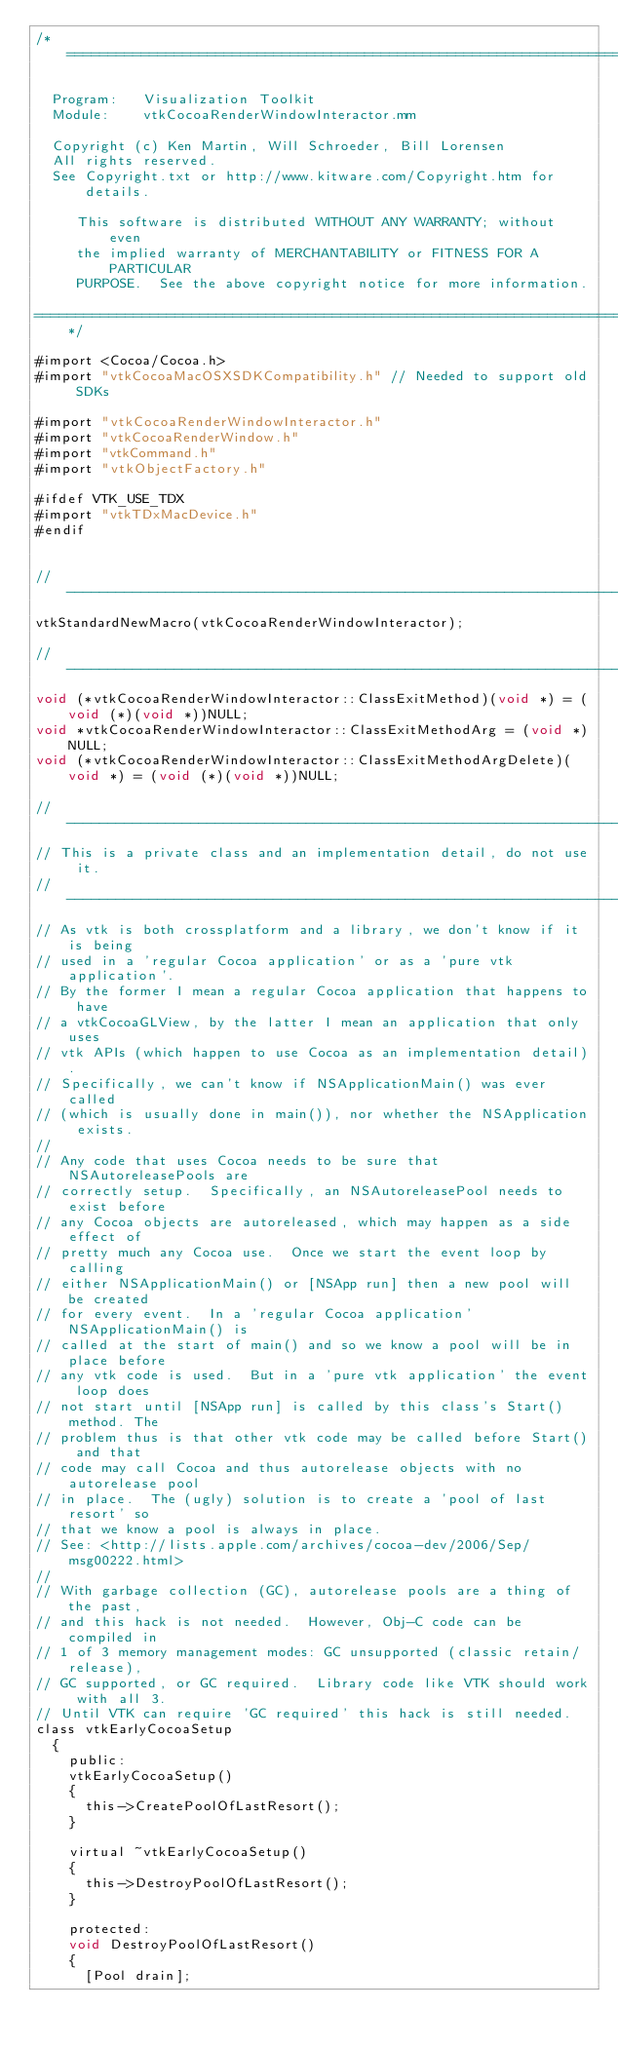<code> <loc_0><loc_0><loc_500><loc_500><_ObjectiveC_>/*=========================================================================

  Program:   Visualization Toolkit
  Module:    vtkCocoaRenderWindowInteractor.mm

  Copyright (c) Ken Martin, Will Schroeder, Bill Lorensen
  All rights reserved.
  See Copyright.txt or http://www.kitware.com/Copyright.htm for details.

     This software is distributed WITHOUT ANY WARRANTY; without even
     the implied warranty of MERCHANTABILITY or FITNESS FOR A PARTICULAR
     PURPOSE.  See the above copyright notice for more information.

=========================================================================*/

#import <Cocoa/Cocoa.h>
#import "vtkCocoaMacOSXSDKCompatibility.h" // Needed to support old SDKs

#import "vtkCocoaRenderWindowInteractor.h"
#import "vtkCocoaRenderWindow.h"
#import "vtkCommand.h"
#import "vtkObjectFactory.h"

#ifdef VTK_USE_TDX
#import "vtkTDxMacDevice.h"
#endif


//----------------------------------------------------------------------------
vtkStandardNewMacro(vtkCocoaRenderWindowInteractor);

//----------------------------------------------------------------------------
void (*vtkCocoaRenderWindowInteractor::ClassExitMethod)(void *) = (void (*)(void *))NULL;
void *vtkCocoaRenderWindowInteractor::ClassExitMethodArg = (void *)NULL;
void (*vtkCocoaRenderWindowInteractor::ClassExitMethodArgDelete)(void *) = (void (*)(void *))NULL;

//----------------------------------------------------------------------------
// This is a private class and an implementation detail, do not use it.
//----------------------------------------------------------------------------
// As vtk is both crossplatform and a library, we don't know if it is being
// used in a 'regular Cocoa application' or as a 'pure vtk application'.
// By the former I mean a regular Cocoa application that happens to have
// a vtkCocoaGLView, by the latter I mean an application that only uses
// vtk APIs (which happen to use Cocoa as an implementation detail).
// Specifically, we can't know if NSApplicationMain() was ever called
// (which is usually done in main()), nor whether the NSApplication exists.
//
// Any code that uses Cocoa needs to be sure that NSAutoreleasePools are
// correctly setup.  Specifically, an NSAutoreleasePool needs to exist before
// any Cocoa objects are autoreleased, which may happen as a side effect of
// pretty much any Cocoa use.  Once we start the event loop by calling
// either NSApplicationMain() or [NSApp run] then a new pool will be created
// for every event.  In a 'regular Cocoa application' NSApplicationMain() is
// called at the start of main() and so we know a pool will be in place before
// any vtk code is used.  But in a 'pure vtk application' the event loop does
// not start until [NSApp run] is called by this class's Start() method. The
// problem thus is that other vtk code may be called before Start() and that
// code may call Cocoa and thus autorelease objects with no autorelease pool
// in place.  The (ugly) solution is to create a 'pool of last resort' so
// that we know a pool is always in place.
// See: <http://lists.apple.com/archives/cocoa-dev/2006/Sep/msg00222.html>
//
// With garbage collection (GC), autorelease pools are a thing of the past,
// and this hack is not needed.  However, Obj-C code can be compiled in
// 1 of 3 memory management modes: GC unsupported (classic retain/release),
// GC supported, or GC required.  Library code like VTK should work with all 3.
// Until VTK can require 'GC required' this hack is still needed.
class vtkEarlyCocoaSetup
  {
    public:
    vtkEarlyCocoaSetup()
    {
      this->CreatePoolOfLastResort();
    }

    virtual ~vtkEarlyCocoaSetup()
    {
      this->DestroyPoolOfLastResort();
    }

    protected:
    void DestroyPoolOfLastResort()
    {
      [Pool drain];</code> 